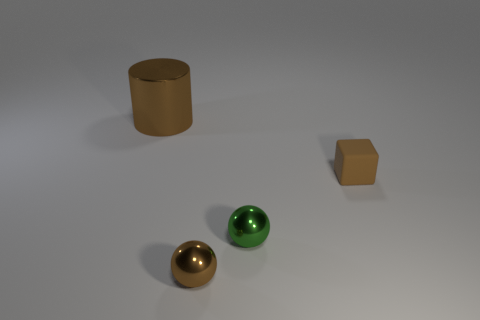Add 4 tiny matte blocks. How many objects exist? 8 Subtract all blocks. How many objects are left? 3 Subtract all large gray metal blocks. Subtract all big brown shiny objects. How many objects are left? 3 Add 1 green things. How many green things are left? 2 Add 1 large shiny objects. How many large shiny objects exist? 2 Subtract 0 purple blocks. How many objects are left? 4 